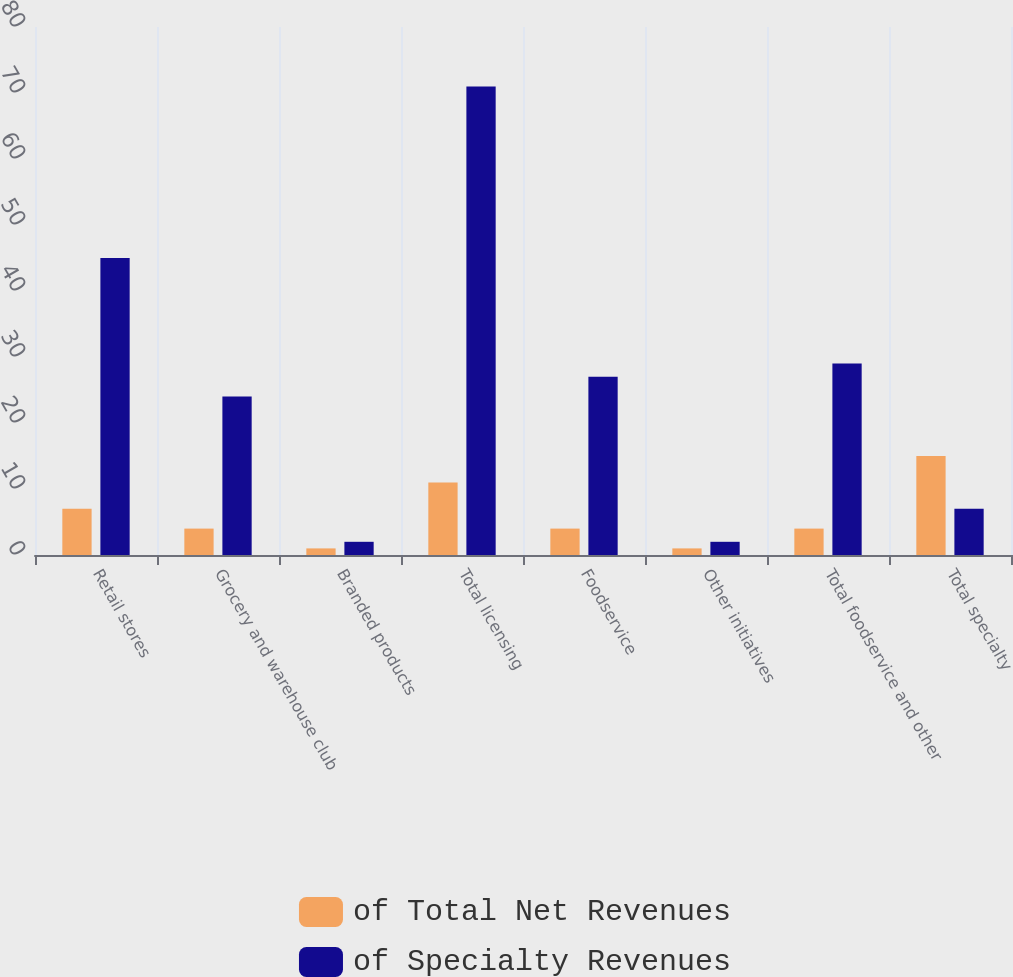<chart> <loc_0><loc_0><loc_500><loc_500><stacked_bar_chart><ecel><fcel>Retail stores<fcel>Grocery and warehouse club<fcel>Branded products<fcel>Total licensing<fcel>Foodservice<fcel>Other initiatives<fcel>Total foodservice and other<fcel>Total specialty<nl><fcel>of Total Net Revenues<fcel>7<fcel>4<fcel>1<fcel>11<fcel>4<fcel>1<fcel>4<fcel>15<nl><fcel>of Specialty Revenues<fcel>45<fcel>24<fcel>2<fcel>71<fcel>27<fcel>2<fcel>29<fcel>7<nl></chart> 